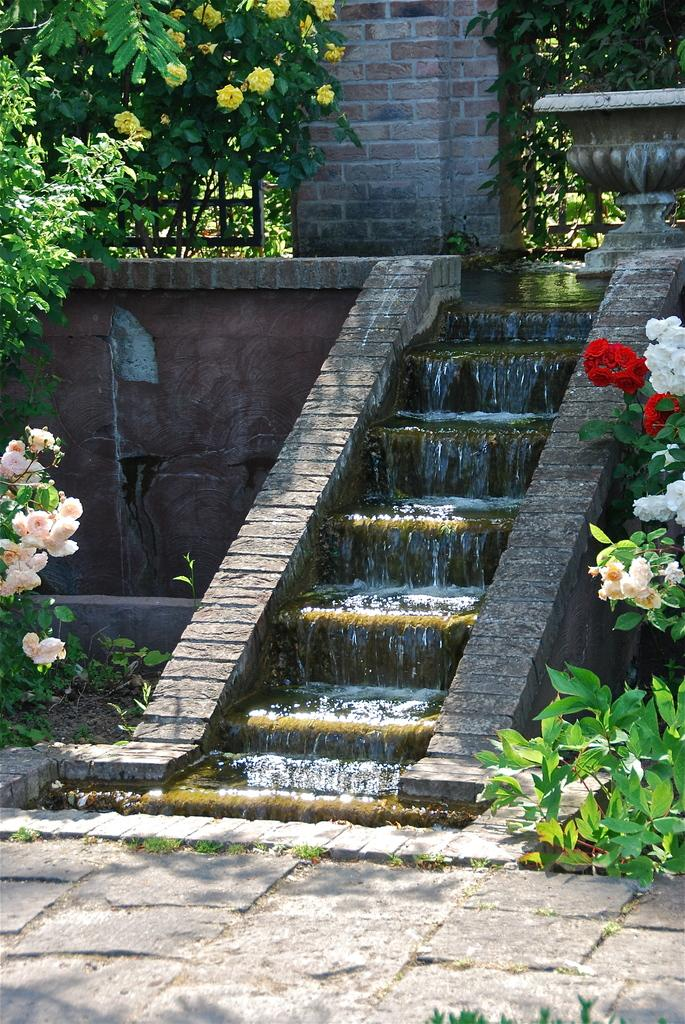What type of vegetation can be seen in the image? There are trees and flowers in the image. What is the path used for in the image? The path in the image suggests a walkway or route for walking. What architectural feature is present in the image? There are steps in the image. What natural element is visible in the image? There is water visible in the image. What is the purpose of the wall in the image? The wall in the image might serve as a boundary or barrier. What is the purpose of the fence in the image? The fence in the image might also serve as a boundary or barrier. Can you hear the bun making sounds in the image? There is no bun present in the image, and therefore no such sound can be heard. Are there any people swimming in the water visible in the image? There is no indication of people swimming in the water visible in the image. 